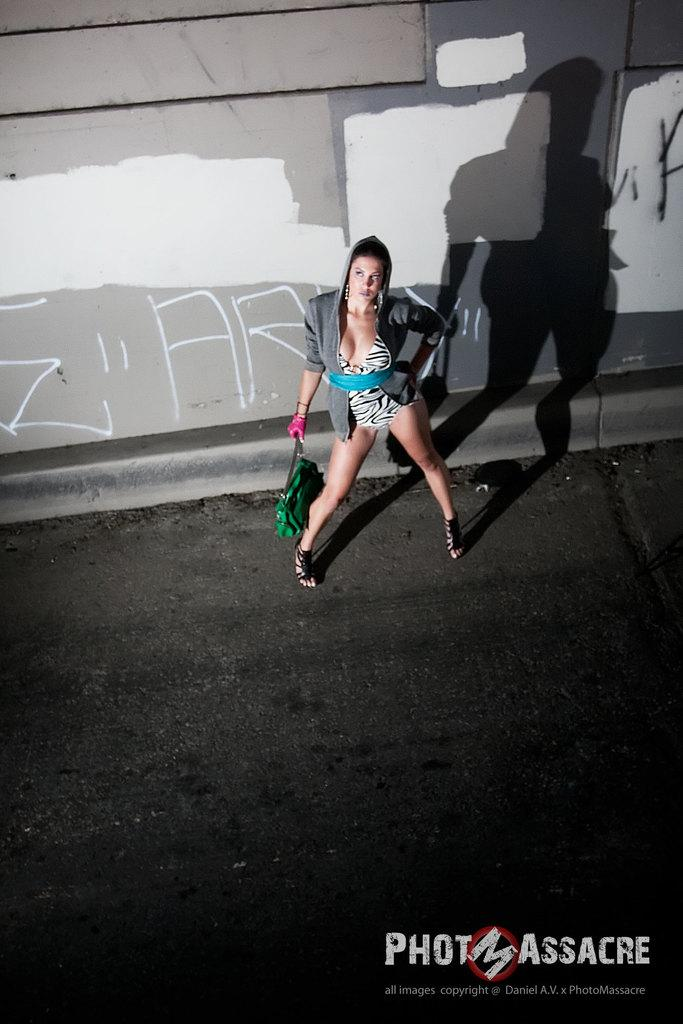What is the person in the image doing? There is a person standing on the road in the image. What is the person holding? The person is holding a bag. What can be seen in the background of the image? There is text on a wall in the background of the image. What text is visible at the bottom of the image? There is text visible at the bottom of the image. Is the person in the image a spy, and what cable are they using to communicate? There is no indication in the image that the person is a spy, nor is there any cable visible for communication purposes. 